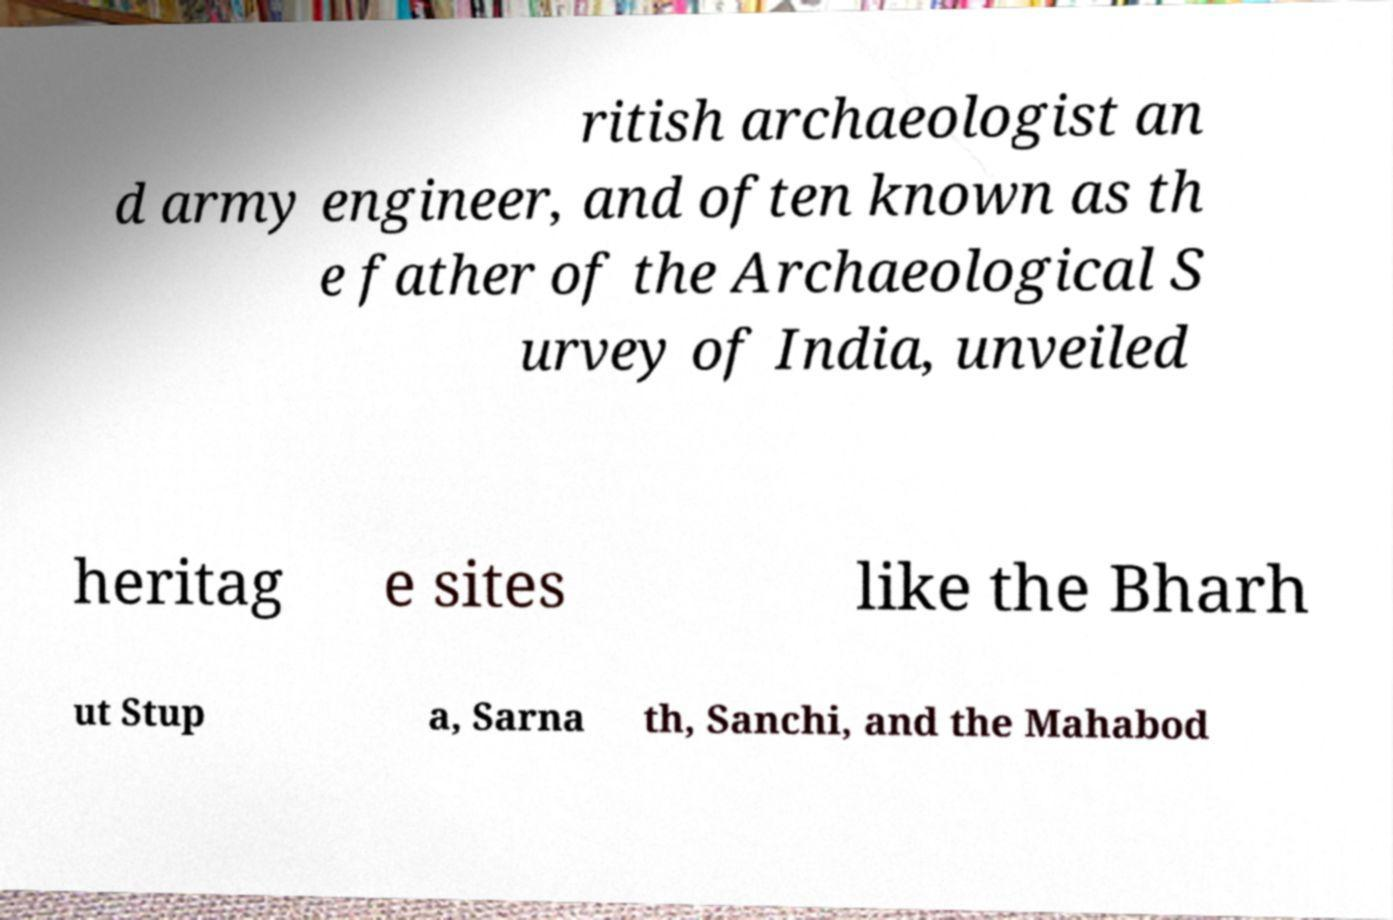I need the written content from this picture converted into text. Can you do that? ritish archaeologist an d army engineer, and often known as th e father of the Archaeological S urvey of India, unveiled heritag e sites like the Bharh ut Stup a, Sarna th, Sanchi, and the Mahabod 